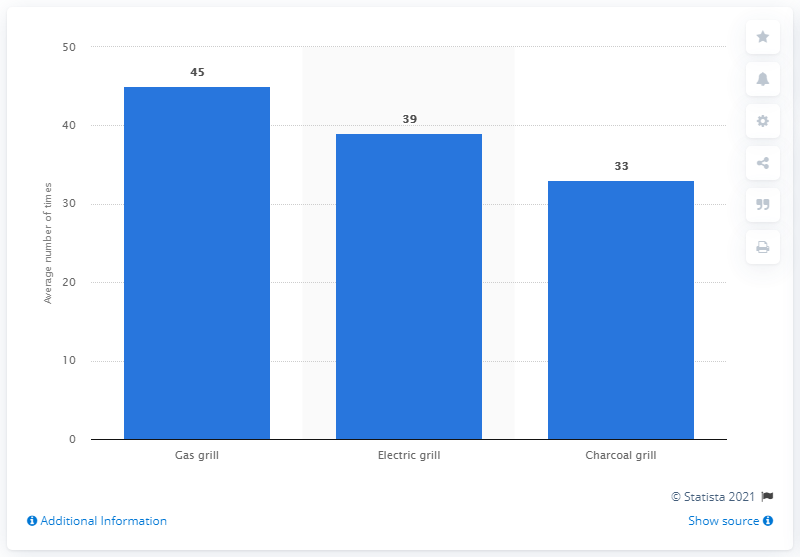Highlight a few significant elements in this photo. During the grilling season in 2011, the average number of gas grills used was 45. 